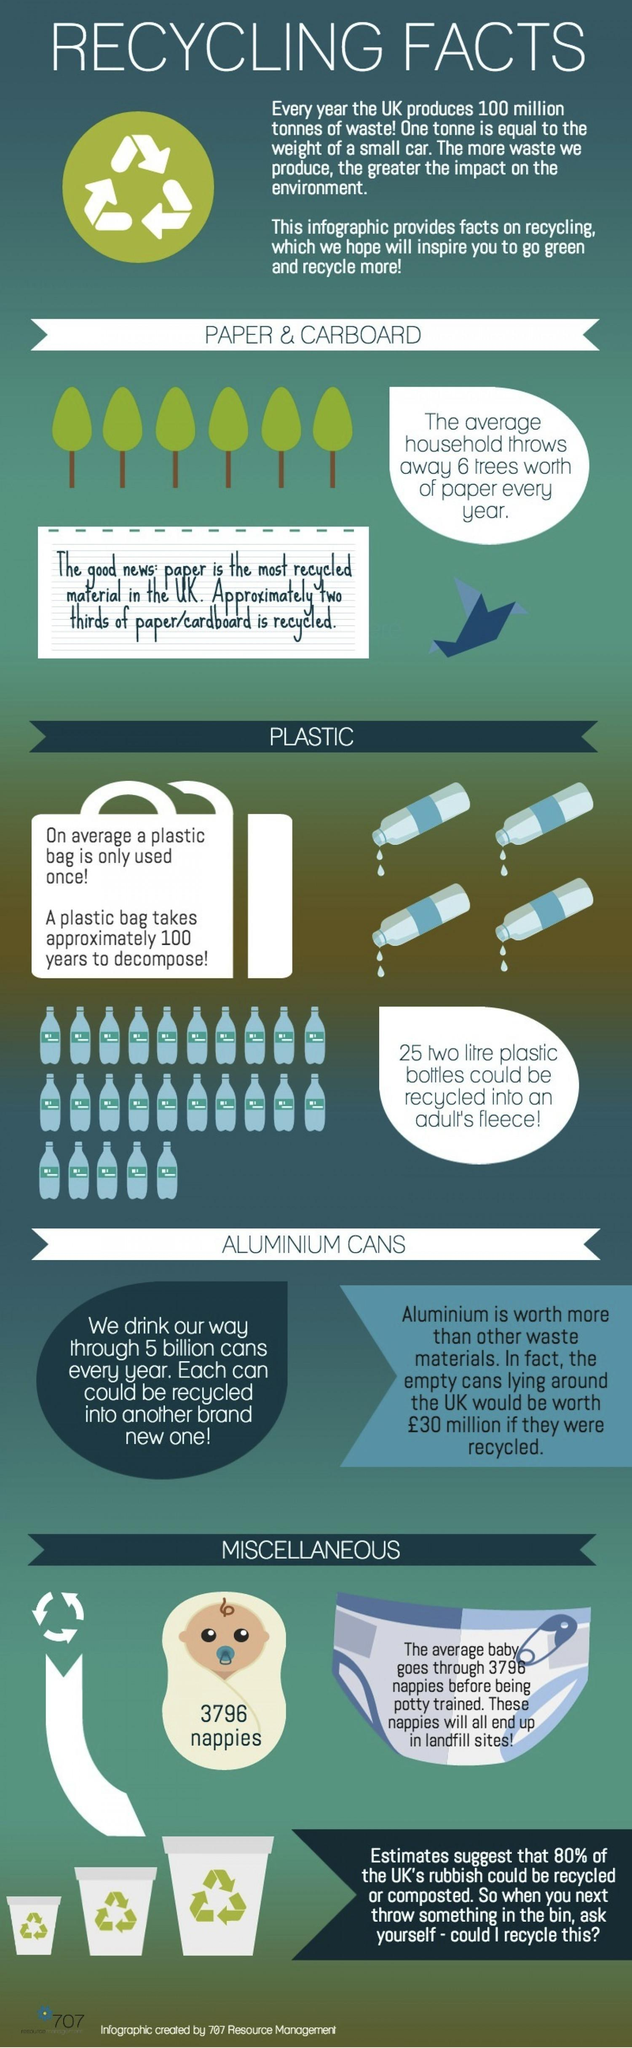Which plastic product takes a century to decompose?
Answer the question with a short phrase. Plastic bag How many recycle bins are shown here? 3 What is written on the image of the baby? 3796 nappies How many trees are shown in the image? 6 Which among these is the most recycled in UK - plastic, paper or aluminium cans Paper How many cans can be recycled from one used can? 1 What percent of UK's rubbish cannot be recycled? 20% How much would empty cans lying around UK be worth if they were recycled (in pounds)? 30 million 